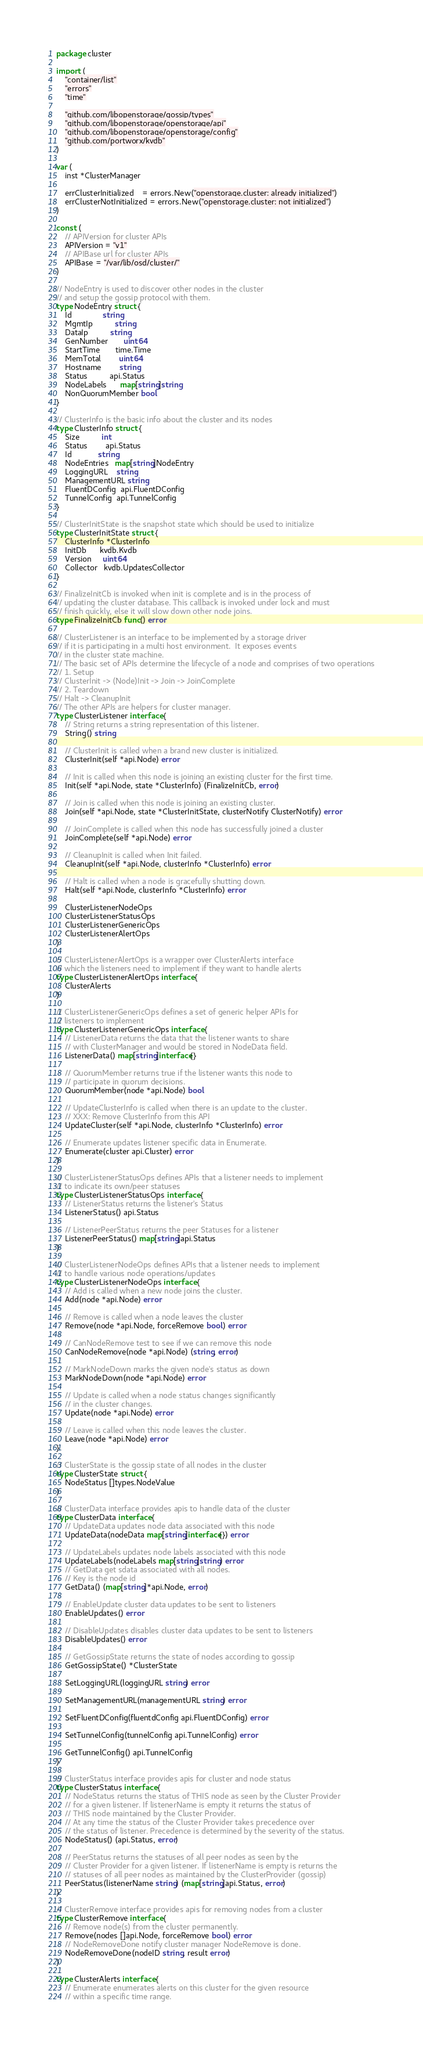Convert code to text. <code><loc_0><loc_0><loc_500><loc_500><_Go_>package cluster

import (
	"container/list"
	"errors"
	"time"

	"github.com/libopenstorage/gossip/types"
	"github.com/libopenstorage/openstorage/api"
	"github.com/libopenstorage/openstorage/config"
	"github.com/portworx/kvdb"
)

var (
	inst *ClusterManager

	errClusterInitialized    = errors.New("openstorage.cluster: already initialized")
	errClusterNotInitialized = errors.New("openstorage.cluster: not initialized")
)

const (
	// APIVersion for cluster APIs
	APIVersion = "v1"
	// APIBase url for cluster APIs
	APIBase = "/var/lib/osd/cluster/"
)

// NodeEntry is used to discover other nodes in the cluster
// and setup the gossip protocol with them.
type NodeEntry struct {
	Id              string
	MgmtIp          string
	DataIp          string
	GenNumber       uint64
	StartTime       time.Time
	MemTotal        uint64
	Hostname        string
	Status          api.Status
	NodeLabels      map[string]string
	NonQuorumMember bool
}

// ClusterInfo is the basic info about the cluster and its nodes
type ClusterInfo struct {
	Size          int
	Status        api.Status
	Id            string
	NodeEntries   map[string]NodeEntry
	LoggingURL    string
	ManagementURL string
	FluentDConfig  api.FluentDConfig
	TunnelConfig  api.TunnelConfig
}

// ClusterInitState is the snapshot state which should be used to initialize
type ClusterInitState struct {
	ClusterInfo *ClusterInfo
	InitDb      kvdb.Kvdb
	Version     uint64
	Collector   kvdb.UpdatesCollector
}

// FinalizeInitCb is invoked when init is complete and is in the process of
// updating the cluster database. This callback is invoked under lock and must
// finish quickly, else it will slow down other node joins.
type FinalizeInitCb func() error

// ClusterListener is an interface to be implemented by a storage driver
// if it is participating in a multi host environment.  It exposes events
// in the cluster state machine.
// The basic set of APIs determine the lifecycle of a node and comprises of two operations
// 1. Setup
// ClusterInit -> (Node)Init -> Join -> JoinComplete
// 2. Teardown
// Halt -> CleanupInit
// The other APIs are helpers for cluster manager.
type ClusterListener interface {
	// String returns a string representation of this listener.
	String() string

	// ClusterInit is called when a brand new cluster is initialized.
	ClusterInit(self *api.Node) error

	// Init is called when this node is joining an existing cluster for the first time.
	Init(self *api.Node, state *ClusterInfo) (FinalizeInitCb, error)

	// Join is called when this node is joining an existing cluster.
	Join(self *api.Node, state *ClusterInitState, clusterNotify ClusterNotify) error

	// JoinComplete is called when this node has successfully joined a cluster
	JoinComplete(self *api.Node) error

	// CleanupInit is called when Init failed.
	CleanupInit(self *api.Node, clusterInfo *ClusterInfo) error

	// Halt is called when a node is gracefully shutting down.
	Halt(self *api.Node, clusterInfo *ClusterInfo) error

	ClusterListenerNodeOps
	ClusterListenerStatusOps
	ClusterListenerGenericOps
	ClusterListenerAlertOps
}

// ClusterListenerAlertOps is a wrapper over ClusterAlerts interface
// which the listeners need to implement if they want to handle alerts
type ClusterListenerAlertOps interface {
	ClusterAlerts
}

// ClusterListenerGenericOps defines a set of generic helper APIs for
// listeners to implement
type ClusterListenerGenericOps interface {
	// ListenerData returns the data that the listener wants to share
	// with ClusterManager and would be stored in NodeData field.
	ListenerData() map[string]interface{}

	// QuorumMember returns true if the listener wants this node to
	// participate in quorum decisions.
	QuorumMember(node *api.Node) bool

	// UpdateClusterInfo is called when there is an update to the cluster.
	// XXX: Remove ClusterInfo from this API
	UpdateCluster(self *api.Node, clusterInfo *ClusterInfo) error

	// Enumerate updates listener specific data in Enumerate.
	Enumerate(cluster api.Cluster) error
}

// ClusterListenerStatusOps defines APIs that a listener needs to implement
// to indicate its own/peer statuses
type ClusterListenerStatusOps interface {
	// ListenerStatus returns the listener's Status
	ListenerStatus() api.Status

	// ListenerPeerStatus returns the peer Statuses for a listener
	ListenerPeerStatus() map[string]api.Status
}

// ClusterListenerNodeOps defines APIs that a listener needs to implement
// to handle various node operations/updates
type ClusterListenerNodeOps interface {
	// Add is called when a new node joins the cluster.
	Add(node *api.Node) error

	// Remove is called when a node leaves the cluster
	Remove(node *api.Node, forceRemove bool) error

	// CanNodeRemove test to see if we can remove this node
	CanNodeRemove(node *api.Node) (string, error)

	// MarkNodeDown marks the given node's status as down
	MarkNodeDown(node *api.Node) error

	// Update is called when a node status changes significantly
	// in the cluster changes.
	Update(node *api.Node) error

	// Leave is called when this node leaves the cluster.
	Leave(node *api.Node) error
}

// ClusterState is the gossip state of all nodes in the cluster
type ClusterState struct {
	NodeStatus []types.NodeValue
}

// ClusterData interface provides apis to handle data of the cluster
type ClusterData interface {
	// UpdateData updates node data associated with this node
	UpdateData(nodeData map[string]interface{}) error

	// UpdateLabels updates node labels associated with this node
	UpdateLabels(nodeLabels map[string]string) error
	// GetData get sdata associated with all nodes.
	// Key is the node id
	GetData() (map[string]*api.Node, error)

	// EnableUpdate cluster data updates to be sent to listeners
	EnableUpdates() error

	// DisableUpdates disables cluster data updates to be sent to listeners
	DisableUpdates() error

	// GetGossipState returns the state of nodes according to gossip
	GetGossipState() *ClusterState

	SetLoggingURL(loggingURL string) error

	SetManagementURL(managementURL string) error

	SetFluentDConfig(fluentdConfig api.FluentDConfig) error

	SetTunnelConfig(tunnelConfig api.TunnelConfig) error

	GetTunnelConfig() api.TunnelConfig
}

// ClusterStatus interface provides apis for cluster and node status
type ClusterStatus interface {
	// NodeStatus returns the status of THIS node as seen by the Cluster Provider
	// for a given listener. If listenerName is empty it returns the status of
	// THIS node maintained by the Cluster Provider.
	// At any time the status of the Cluster Provider takes precedence over
	// the status of listener. Precedence is determined by the severity of the status.
	NodeStatus() (api.Status, error)

	// PeerStatus returns the statuses of all peer nodes as seen by the
	// Cluster Provider for a given listener. If listenerName is empty is returns the
	// statuses of all peer nodes as maintained by the ClusterProvider (gossip)
	PeerStatus(listenerName string) (map[string]api.Status, error)
}

// ClusterRemove interface provides apis for removing nodes from a cluster
type ClusterRemove interface {
	// Remove node(s) from the cluster permanently.
	Remove(nodes []api.Node, forceRemove bool) error
	// NodeRemoveDone notify cluster manager NodeRemove is done.
	NodeRemoveDone(nodeID string, result error)
}

type ClusterAlerts interface {
	// Enumerate enumerates alerts on this cluster for the given resource
	// within a specific time range.</code> 